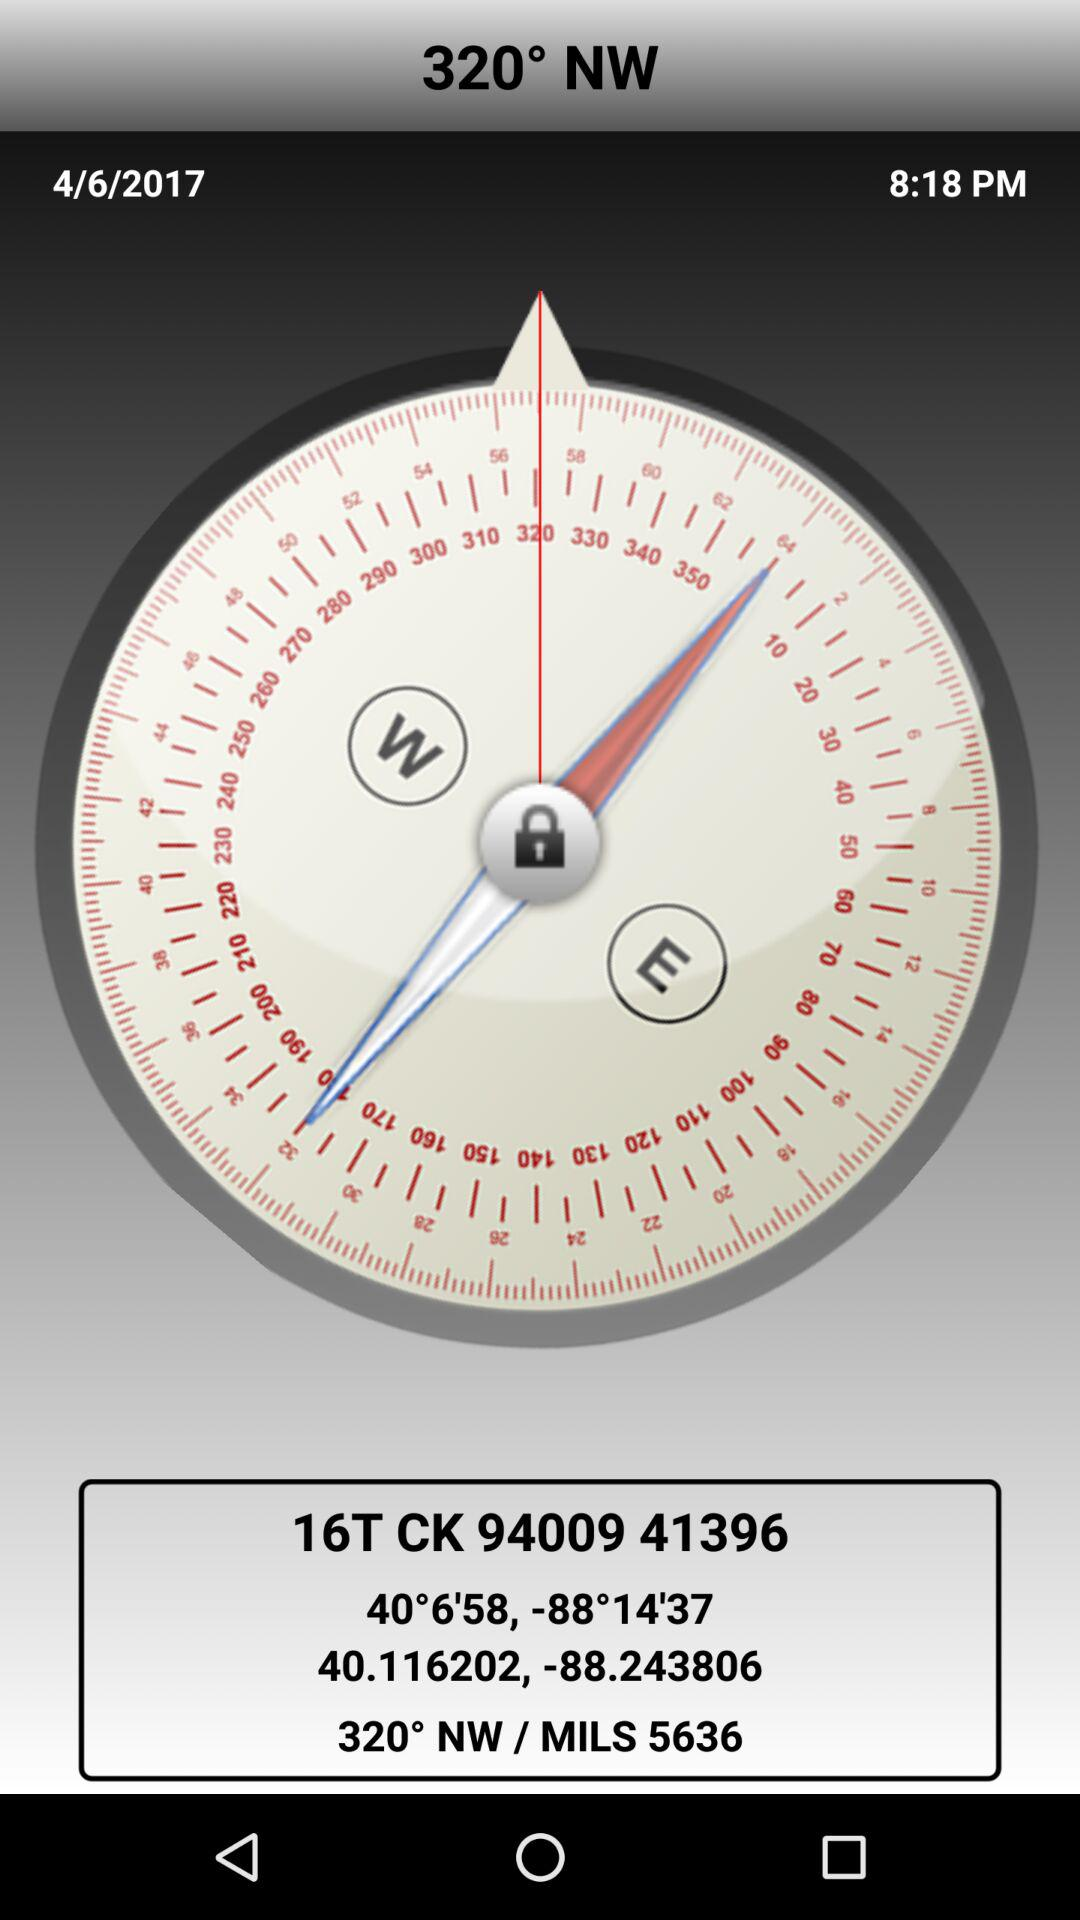What is the mentioned time? The mentioned time is 8:18 PM. 